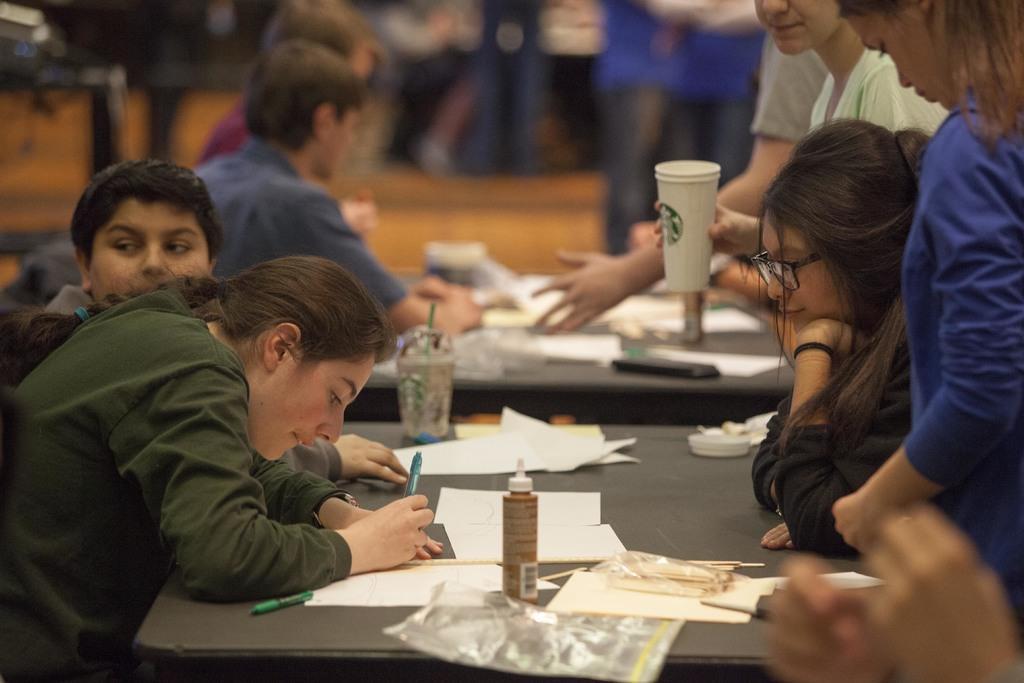In one or two sentences, can you explain what this image depicts? In this picture I can see people among them some are sitting and some are standing. Here I can see a person is holding a white color glass. On the table I can see papers, pens and some other objects. The woman on the left side is holding a pen. On the right side I can see a woman is wearing spectacles. The background of the image is blur. 